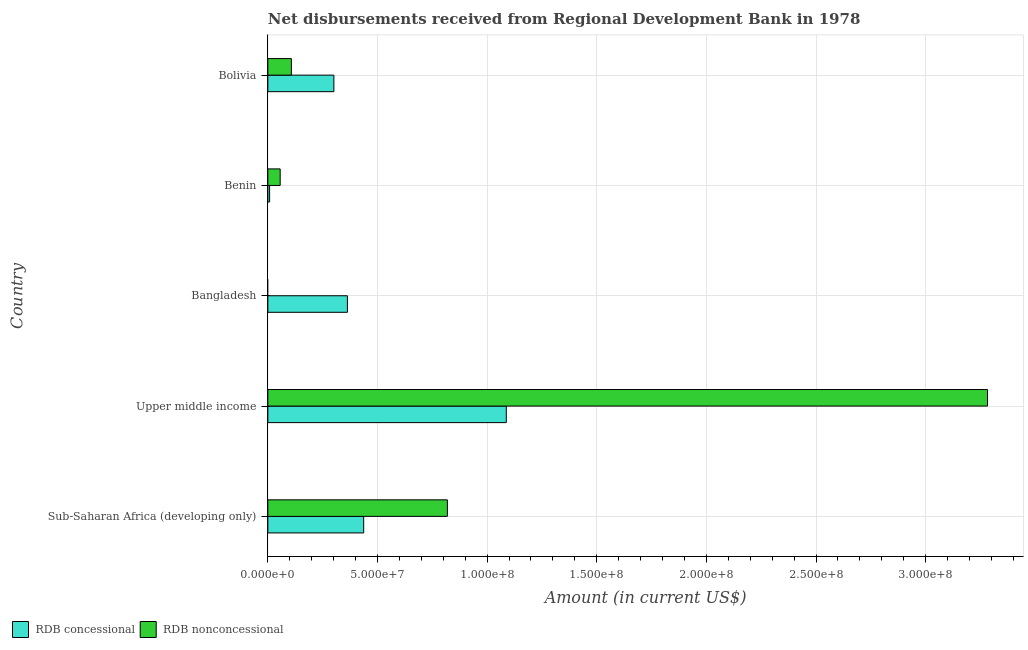How many different coloured bars are there?
Provide a succinct answer. 2. How many bars are there on the 3rd tick from the top?
Your answer should be compact. 1. How many bars are there on the 2nd tick from the bottom?
Offer a very short reply. 2. What is the net non concessional disbursements from rdb in Benin?
Your answer should be very brief. 5.62e+06. Across all countries, what is the maximum net non concessional disbursements from rdb?
Offer a very short reply. 3.28e+08. Across all countries, what is the minimum net concessional disbursements from rdb?
Offer a terse response. 8.06e+05. In which country was the net concessional disbursements from rdb maximum?
Make the answer very short. Upper middle income. What is the total net non concessional disbursements from rdb in the graph?
Your response must be concise. 4.26e+08. What is the difference between the net concessional disbursements from rdb in Sub-Saharan Africa (developing only) and that in Upper middle income?
Give a very brief answer. -6.50e+07. What is the difference between the net non concessional disbursements from rdb in Bangladesh and the net concessional disbursements from rdb in Bolivia?
Your answer should be compact. -3.01e+07. What is the average net concessional disbursements from rdb per country?
Your answer should be compact. 4.39e+07. What is the difference between the net concessional disbursements from rdb and net non concessional disbursements from rdb in Benin?
Give a very brief answer. -4.82e+06. What is the ratio of the net concessional disbursements from rdb in Bangladesh to that in Sub-Saharan Africa (developing only)?
Your answer should be very brief. 0.83. Is the net non concessional disbursements from rdb in Bolivia less than that in Upper middle income?
Your response must be concise. Yes. What is the difference between the highest and the second highest net non concessional disbursements from rdb?
Provide a succinct answer. 2.46e+08. What is the difference between the highest and the lowest net concessional disbursements from rdb?
Your answer should be compact. 1.08e+08. In how many countries, is the net concessional disbursements from rdb greater than the average net concessional disbursements from rdb taken over all countries?
Give a very brief answer. 1. Is the sum of the net concessional disbursements from rdb in Benin and Bolivia greater than the maximum net non concessional disbursements from rdb across all countries?
Ensure brevity in your answer.  No. Are the values on the major ticks of X-axis written in scientific E-notation?
Your answer should be very brief. Yes. Does the graph contain grids?
Offer a terse response. Yes. Where does the legend appear in the graph?
Keep it short and to the point. Bottom left. How are the legend labels stacked?
Your answer should be very brief. Horizontal. What is the title of the graph?
Offer a terse response. Net disbursements received from Regional Development Bank in 1978. Does "Goods" appear as one of the legend labels in the graph?
Provide a short and direct response. No. What is the label or title of the Y-axis?
Give a very brief answer. Country. What is the Amount (in current US$) of RDB concessional in Sub-Saharan Africa (developing only)?
Your response must be concise. 4.37e+07. What is the Amount (in current US$) in RDB nonconcessional in Sub-Saharan Africa (developing only)?
Provide a succinct answer. 8.19e+07. What is the Amount (in current US$) in RDB concessional in Upper middle income?
Provide a short and direct response. 1.09e+08. What is the Amount (in current US$) in RDB nonconcessional in Upper middle income?
Ensure brevity in your answer.  3.28e+08. What is the Amount (in current US$) of RDB concessional in Bangladesh?
Your answer should be compact. 3.63e+07. What is the Amount (in current US$) of RDB concessional in Benin?
Offer a terse response. 8.06e+05. What is the Amount (in current US$) of RDB nonconcessional in Benin?
Give a very brief answer. 5.62e+06. What is the Amount (in current US$) in RDB concessional in Bolivia?
Your answer should be very brief. 3.01e+07. What is the Amount (in current US$) in RDB nonconcessional in Bolivia?
Your answer should be very brief. 1.07e+07. Across all countries, what is the maximum Amount (in current US$) of RDB concessional?
Give a very brief answer. 1.09e+08. Across all countries, what is the maximum Amount (in current US$) of RDB nonconcessional?
Offer a very short reply. 3.28e+08. Across all countries, what is the minimum Amount (in current US$) of RDB concessional?
Give a very brief answer. 8.06e+05. What is the total Amount (in current US$) of RDB concessional in the graph?
Your response must be concise. 2.20e+08. What is the total Amount (in current US$) of RDB nonconcessional in the graph?
Make the answer very short. 4.26e+08. What is the difference between the Amount (in current US$) of RDB concessional in Sub-Saharan Africa (developing only) and that in Upper middle income?
Provide a short and direct response. -6.50e+07. What is the difference between the Amount (in current US$) of RDB nonconcessional in Sub-Saharan Africa (developing only) and that in Upper middle income?
Offer a very short reply. -2.46e+08. What is the difference between the Amount (in current US$) in RDB concessional in Sub-Saharan Africa (developing only) and that in Bangladesh?
Make the answer very short. 7.42e+06. What is the difference between the Amount (in current US$) in RDB concessional in Sub-Saharan Africa (developing only) and that in Benin?
Make the answer very short. 4.29e+07. What is the difference between the Amount (in current US$) of RDB nonconcessional in Sub-Saharan Africa (developing only) and that in Benin?
Provide a short and direct response. 7.63e+07. What is the difference between the Amount (in current US$) of RDB concessional in Sub-Saharan Africa (developing only) and that in Bolivia?
Make the answer very short. 1.36e+07. What is the difference between the Amount (in current US$) of RDB nonconcessional in Sub-Saharan Africa (developing only) and that in Bolivia?
Your answer should be very brief. 7.12e+07. What is the difference between the Amount (in current US$) in RDB concessional in Upper middle income and that in Bangladesh?
Provide a succinct answer. 7.25e+07. What is the difference between the Amount (in current US$) of RDB concessional in Upper middle income and that in Benin?
Your answer should be very brief. 1.08e+08. What is the difference between the Amount (in current US$) in RDB nonconcessional in Upper middle income and that in Benin?
Offer a very short reply. 3.23e+08. What is the difference between the Amount (in current US$) in RDB concessional in Upper middle income and that in Bolivia?
Your answer should be compact. 7.86e+07. What is the difference between the Amount (in current US$) in RDB nonconcessional in Upper middle income and that in Bolivia?
Ensure brevity in your answer.  3.17e+08. What is the difference between the Amount (in current US$) in RDB concessional in Bangladesh and that in Benin?
Your answer should be very brief. 3.55e+07. What is the difference between the Amount (in current US$) of RDB concessional in Bangladesh and that in Bolivia?
Give a very brief answer. 6.17e+06. What is the difference between the Amount (in current US$) of RDB concessional in Benin and that in Bolivia?
Provide a succinct answer. -2.93e+07. What is the difference between the Amount (in current US$) of RDB nonconcessional in Benin and that in Bolivia?
Provide a succinct answer. -5.10e+06. What is the difference between the Amount (in current US$) in RDB concessional in Sub-Saharan Africa (developing only) and the Amount (in current US$) in RDB nonconcessional in Upper middle income?
Give a very brief answer. -2.85e+08. What is the difference between the Amount (in current US$) in RDB concessional in Sub-Saharan Africa (developing only) and the Amount (in current US$) in RDB nonconcessional in Benin?
Provide a succinct answer. 3.81e+07. What is the difference between the Amount (in current US$) of RDB concessional in Sub-Saharan Africa (developing only) and the Amount (in current US$) of RDB nonconcessional in Bolivia?
Give a very brief answer. 3.30e+07. What is the difference between the Amount (in current US$) of RDB concessional in Upper middle income and the Amount (in current US$) of RDB nonconcessional in Benin?
Keep it short and to the point. 1.03e+08. What is the difference between the Amount (in current US$) of RDB concessional in Upper middle income and the Amount (in current US$) of RDB nonconcessional in Bolivia?
Provide a short and direct response. 9.80e+07. What is the difference between the Amount (in current US$) of RDB concessional in Bangladesh and the Amount (in current US$) of RDB nonconcessional in Benin?
Your response must be concise. 3.07e+07. What is the difference between the Amount (in current US$) of RDB concessional in Bangladesh and the Amount (in current US$) of RDB nonconcessional in Bolivia?
Provide a short and direct response. 2.56e+07. What is the difference between the Amount (in current US$) in RDB concessional in Benin and the Amount (in current US$) in RDB nonconcessional in Bolivia?
Offer a very short reply. -9.92e+06. What is the average Amount (in current US$) in RDB concessional per country?
Provide a short and direct response. 4.39e+07. What is the average Amount (in current US$) of RDB nonconcessional per country?
Offer a very short reply. 8.53e+07. What is the difference between the Amount (in current US$) of RDB concessional and Amount (in current US$) of RDB nonconcessional in Sub-Saharan Africa (developing only)?
Give a very brief answer. -3.82e+07. What is the difference between the Amount (in current US$) of RDB concessional and Amount (in current US$) of RDB nonconcessional in Upper middle income?
Provide a short and direct response. -2.19e+08. What is the difference between the Amount (in current US$) of RDB concessional and Amount (in current US$) of RDB nonconcessional in Benin?
Offer a terse response. -4.82e+06. What is the difference between the Amount (in current US$) of RDB concessional and Amount (in current US$) of RDB nonconcessional in Bolivia?
Ensure brevity in your answer.  1.94e+07. What is the ratio of the Amount (in current US$) of RDB concessional in Sub-Saharan Africa (developing only) to that in Upper middle income?
Give a very brief answer. 0.4. What is the ratio of the Amount (in current US$) in RDB nonconcessional in Sub-Saharan Africa (developing only) to that in Upper middle income?
Your response must be concise. 0.25. What is the ratio of the Amount (in current US$) in RDB concessional in Sub-Saharan Africa (developing only) to that in Bangladesh?
Provide a short and direct response. 1.2. What is the ratio of the Amount (in current US$) in RDB concessional in Sub-Saharan Africa (developing only) to that in Benin?
Your answer should be compact. 54.23. What is the ratio of the Amount (in current US$) in RDB nonconcessional in Sub-Saharan Africa (developing only) to that in Benin?
Give a very brief answer. 14.56. What is the ratio of the Amount (in current US$) of RDB concessional in Sub-Saharan Africa (developing only) to that in Bolivia?
Your answer should be very brief. 1.45. What is the ratio of the Amount (in current US$) in RDB nonconcessional in Sub-Saharan Africa (developing only) to that in Bolivia?
Your response must be concise. 7.64. What is the ratio of the Amount (in current US$) of RDB concessional in Upper middle income to that in Bangladesh?
Keep it short and to the point. 3. What is the ratio of the Amount (in current US$) of RDB concessional in Upper middle income to that in Benin?
Offer a terse response. 134.93. What is the ratio of the Amount (in current US$) in RDB nonconcessional in Upper middle income to that in Benin?
Offer a terse response. 58.35. What is the ratio of the Amount (in current US$) in RDB concessional in Upper middle income to that in Bolivia?
Your response must be concise. 3.61. What is the ratio of the Amount (in current US$) in RDB nonconcessional in Upper middle income to that in Bolivia?
Ensure brevity in your answer.  30.61. What is the ratio of the Amount (in current US$) in RDB concessional in Bangladesh to that in Benin?
Provide a short and direct response. 45.02. What is the ratio of the Amount (in current US$) in RDB concessional in Bangladesh to that in Bolivia?
Make the answer very short. 1.21. What is the ratio of the Amount (in current US$) in RDB concessional in Benin to that in Bolivia?
Your answer should be compact. 0.03. What is the ratio of the Amount (in current US$) of RDB nonconcessional in Benin to that in Bolivia?
Provide a succinct answer. 0.52. What is the difference between the highest and the second highest Amount (in current US$) in RDB concessional?
Provide a succinct answer. 6.50e+07. What is the difference between the highest and the second highest Amount (in current US$) in RDB nonconcessional?
Offer a very short reply. 2.46e+08. What is the difference between the highest and the lowest Amount (in current US$) in RDB concessional?
Ensure brevity in your answer.  1.08e+08. What is the difference between the highest and the lowest Amount (in current US$) in RDB nonconcessional?
Make the answer very short. 3.28e+08. 